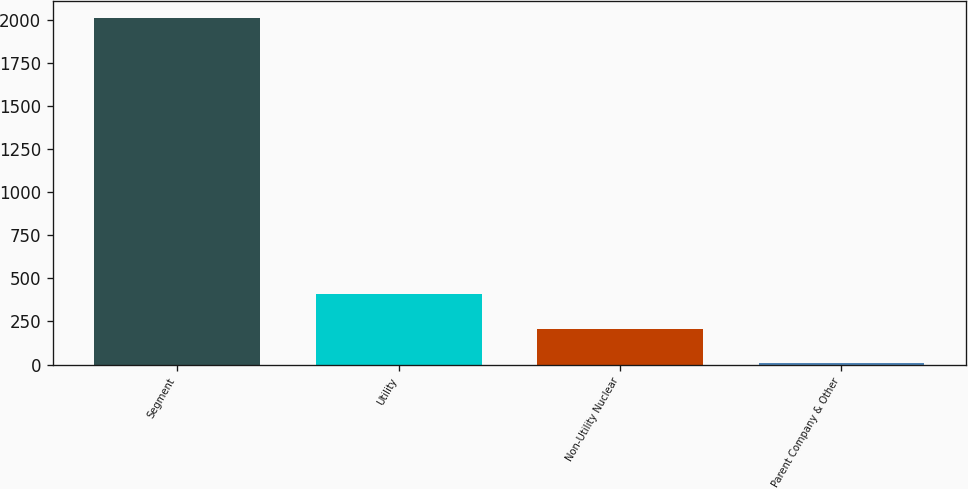Convert chart. <chart><loc_0><loc_0><loc_500><loc_500><bar_chart><fcel>Segment<fcel>Utility<fcel>Non-Utility Nuclear<fcel>Parent Company & Other<nl><fcel>2009<fcel>407.4<fcel>207.2<fcel>7<nl></chart> 